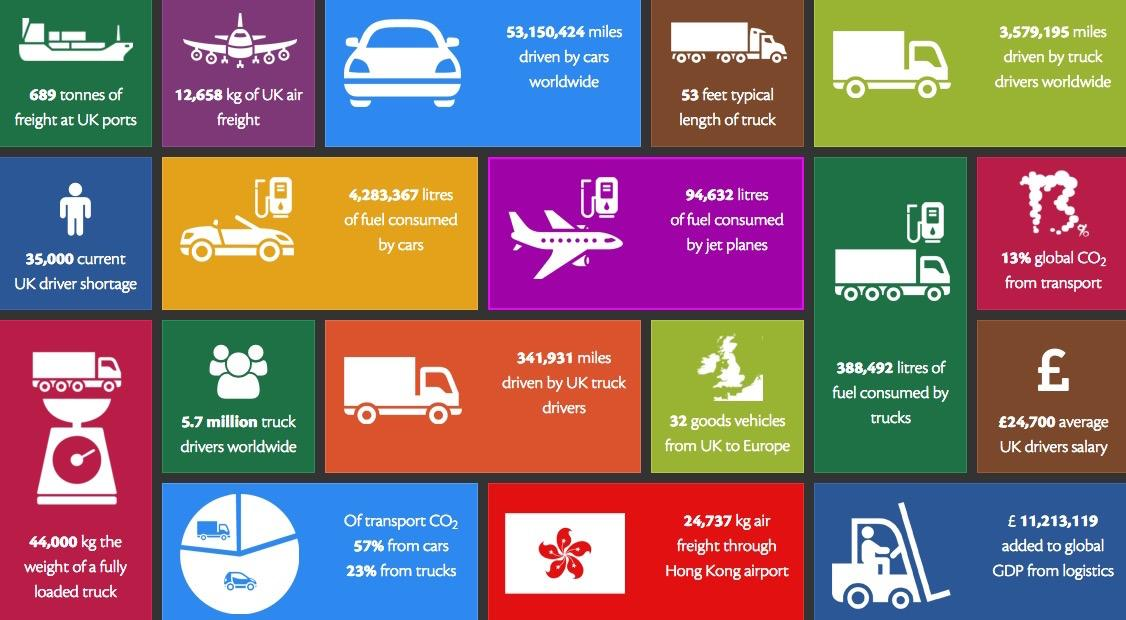Highlight a few significant elements in this photo. This infographic features 5 images of trucks. The difference in percentage of CO2 emissions between cars and trucks is 34%. The infographic contains two images of planes. According to data, fuel consumption is higher for cars compared to trucks and jet planes. In particular, cars have a higher fuel consumption than these other modes of transportation. The difference in liters between the fuel consumed by cars and trucks is 3894875.. 